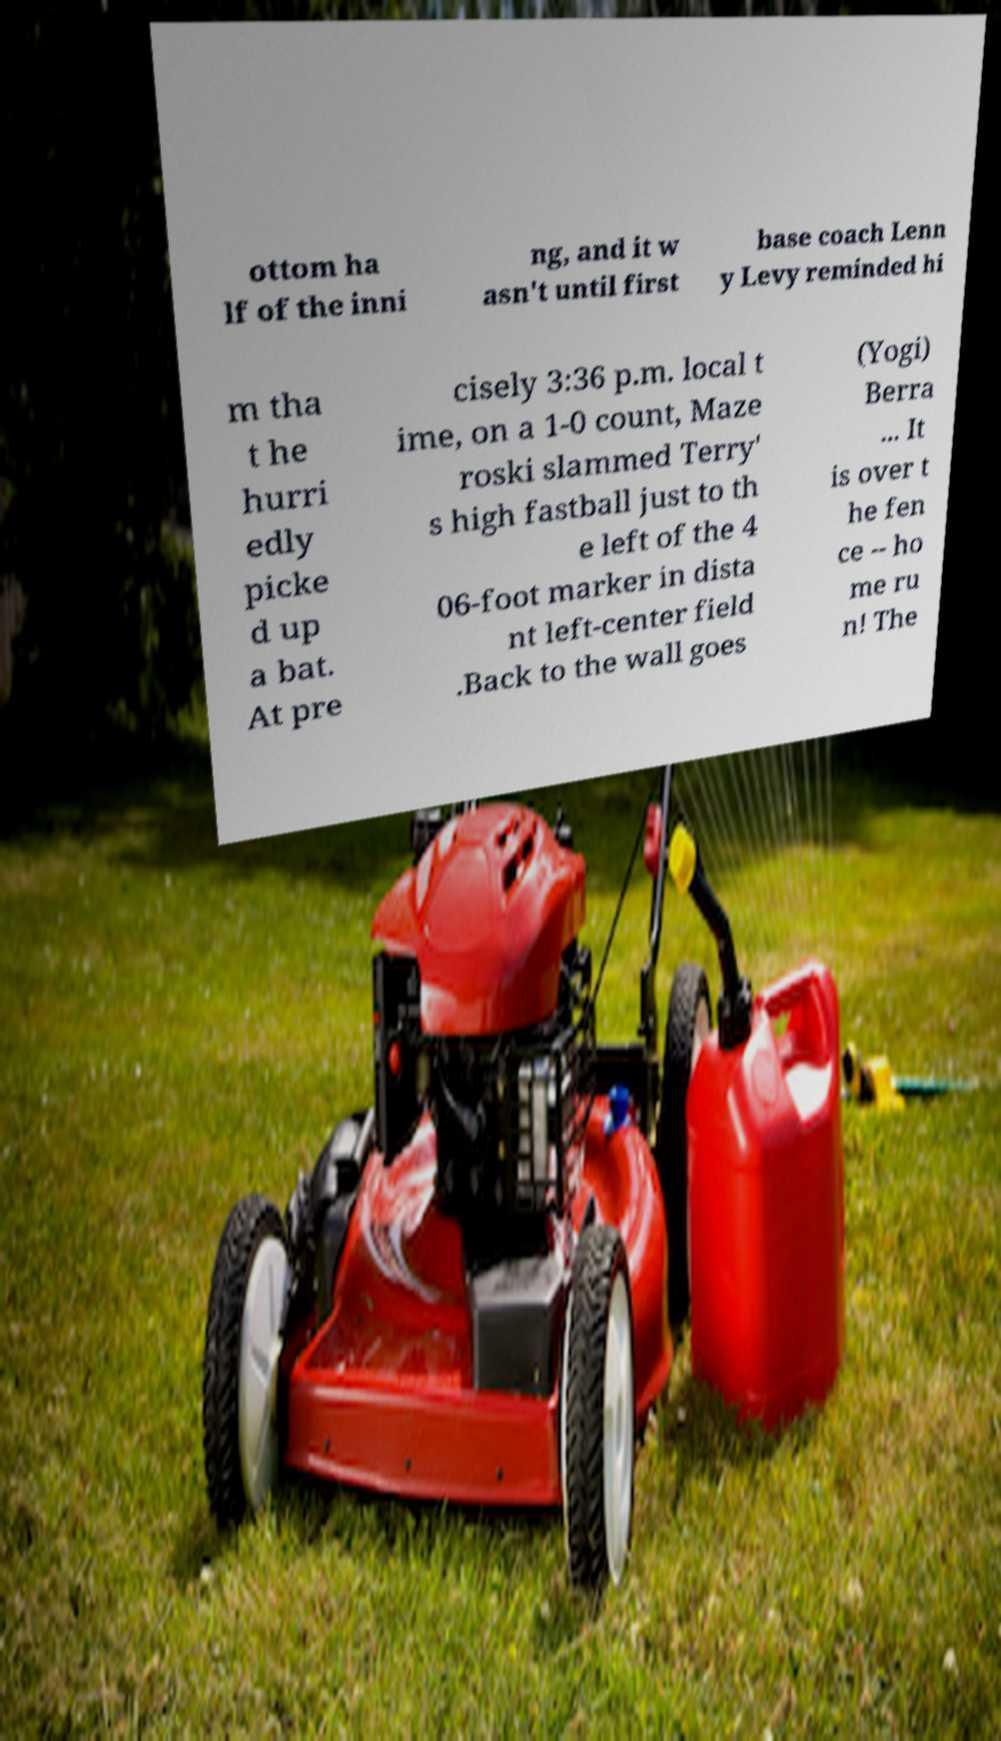Could you extract and type out the text from this image? ottom ha lf of the inni ng, and it w asn't until first base coach Lenn y Levy reminded hi m tha t he hurri edly picke d up a bat. At pre cisely 3:36 p.m. local t ime, on a 1-0 count, Maze roski slammed Terry' s high fastball just to th e left of the 4 06-foot marker in dista nt left-center field .Back to the wall goes (Yogi) Berra ... It is over t he fen ce -- ho me ru n! The 